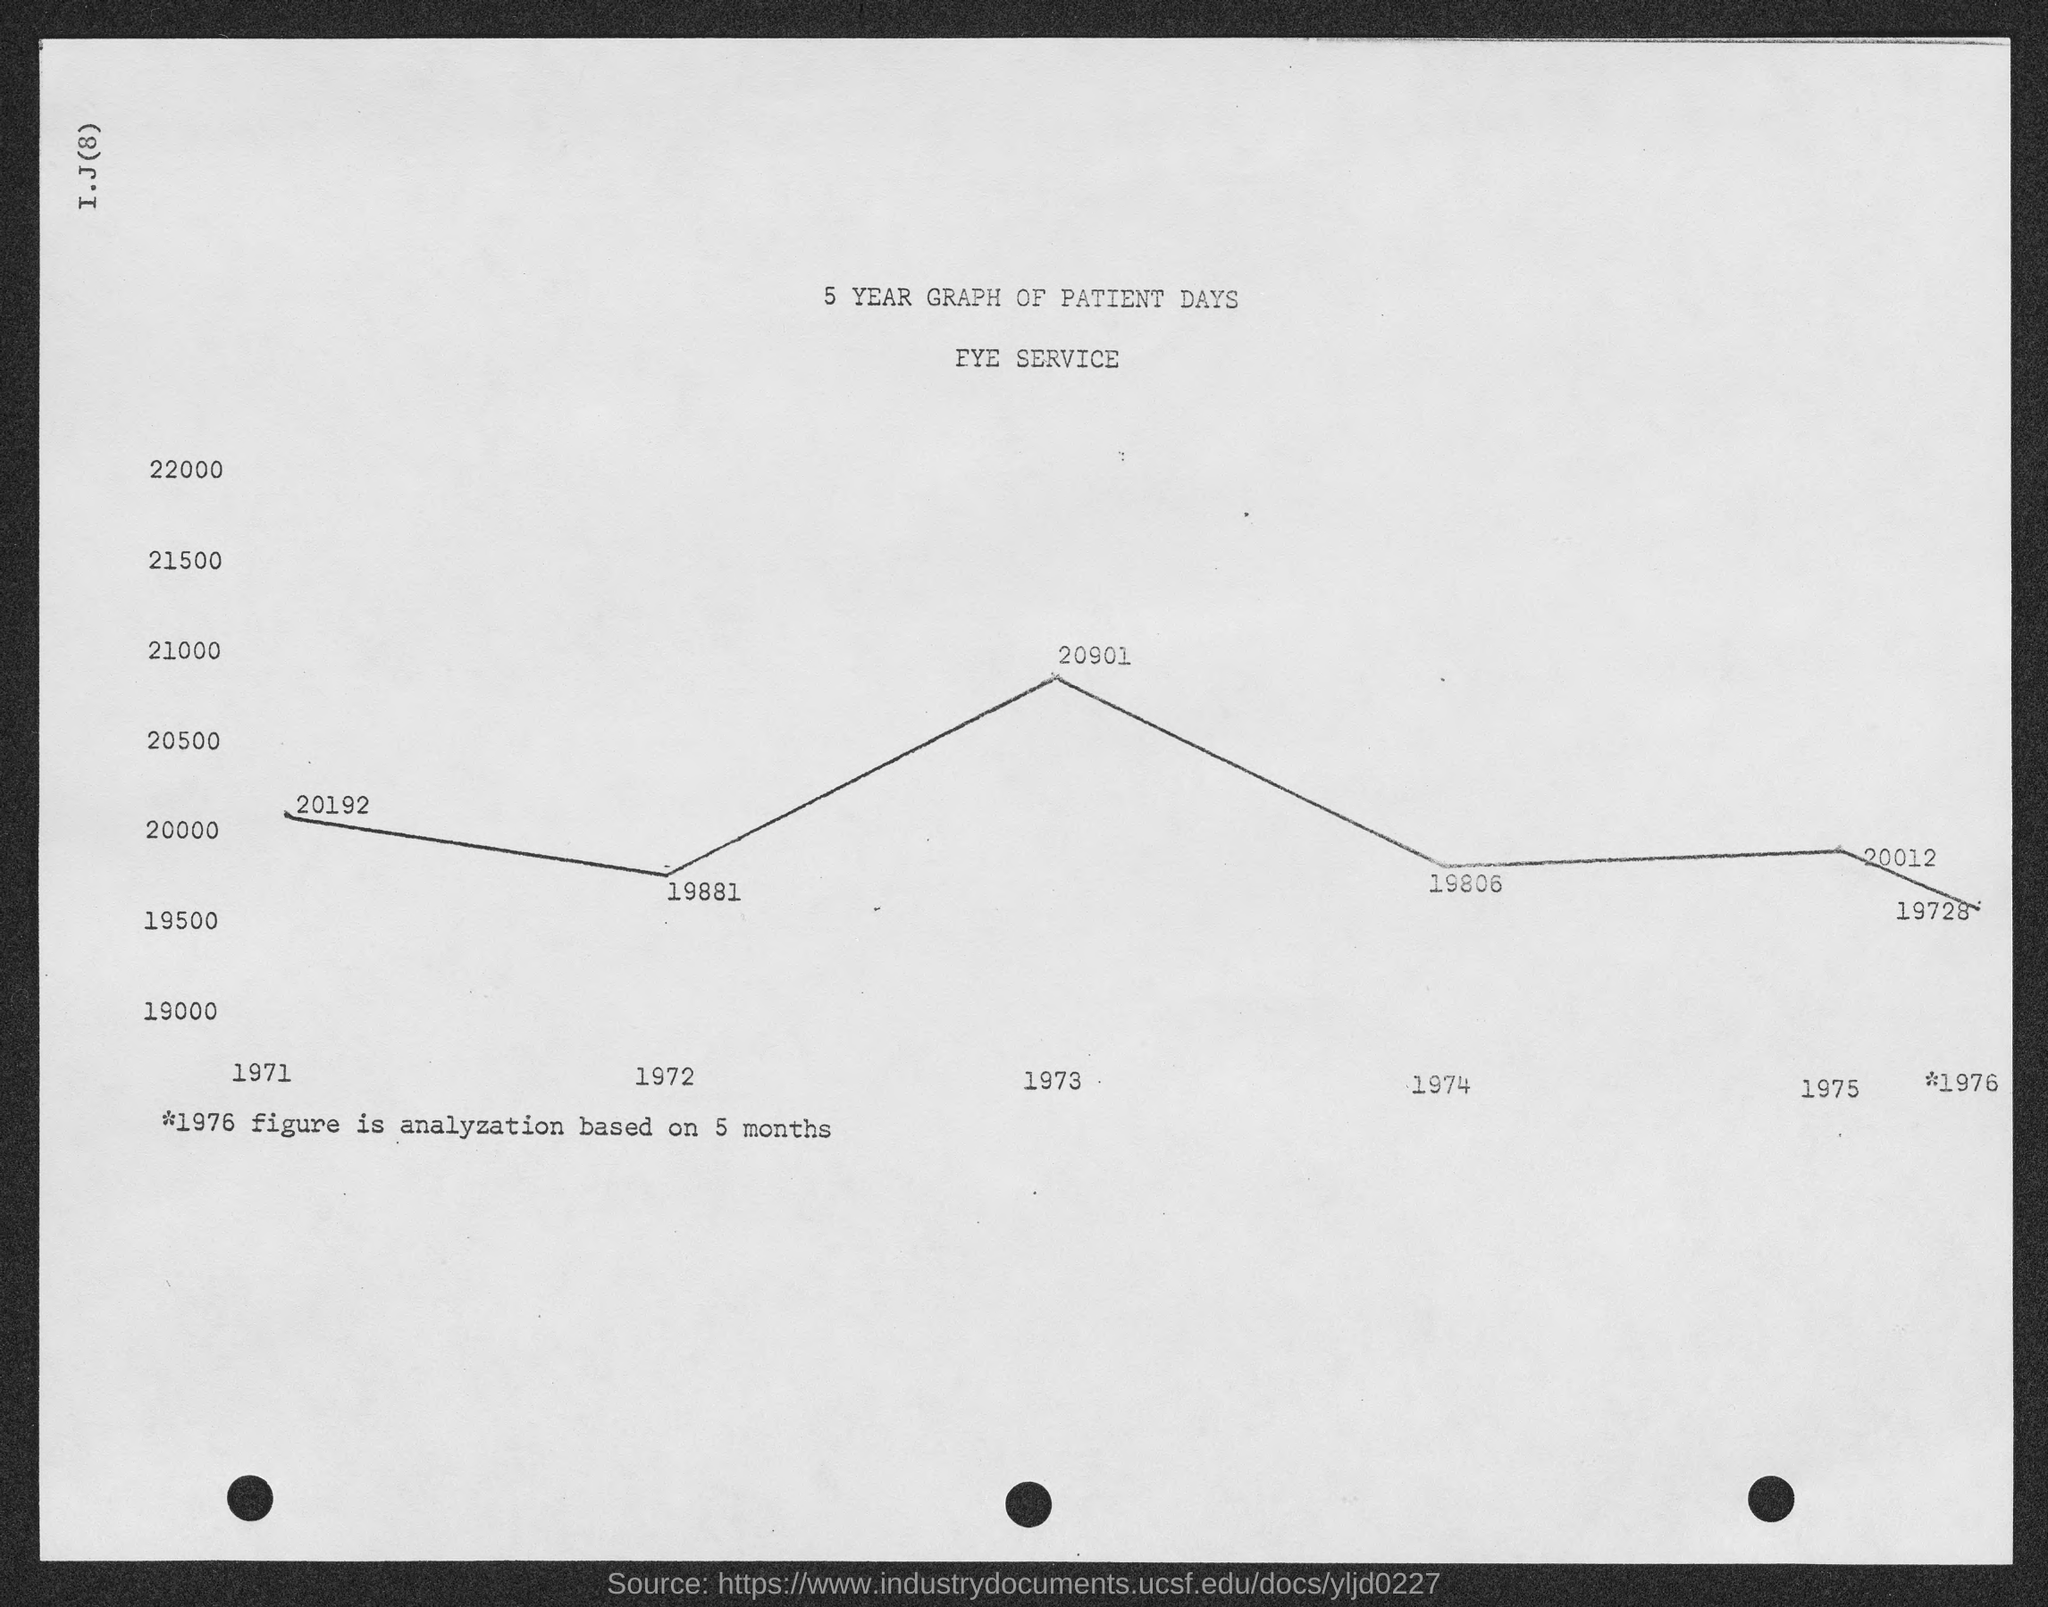What is the heading mentioned in the given page ?
Your answer should be very brief. 5 year graph of patient days. What is the name of the service mentioned in the given page ?
Ensure brevity in your answer.  Eye service. What is the value in the year 1971 as mentioned in the given form ?
Your answer should be very brief. 20192. What is the value in the year 1972 as mentioned in the given form ?
Give a very brief answer. 19881. What is the value in the year 1973 as mentioned in the given form ?
Offer a very short reply. 20901. What is the value in the year 1974 as mentioned in the given form ?
Provide a short and direct response. 19806. 